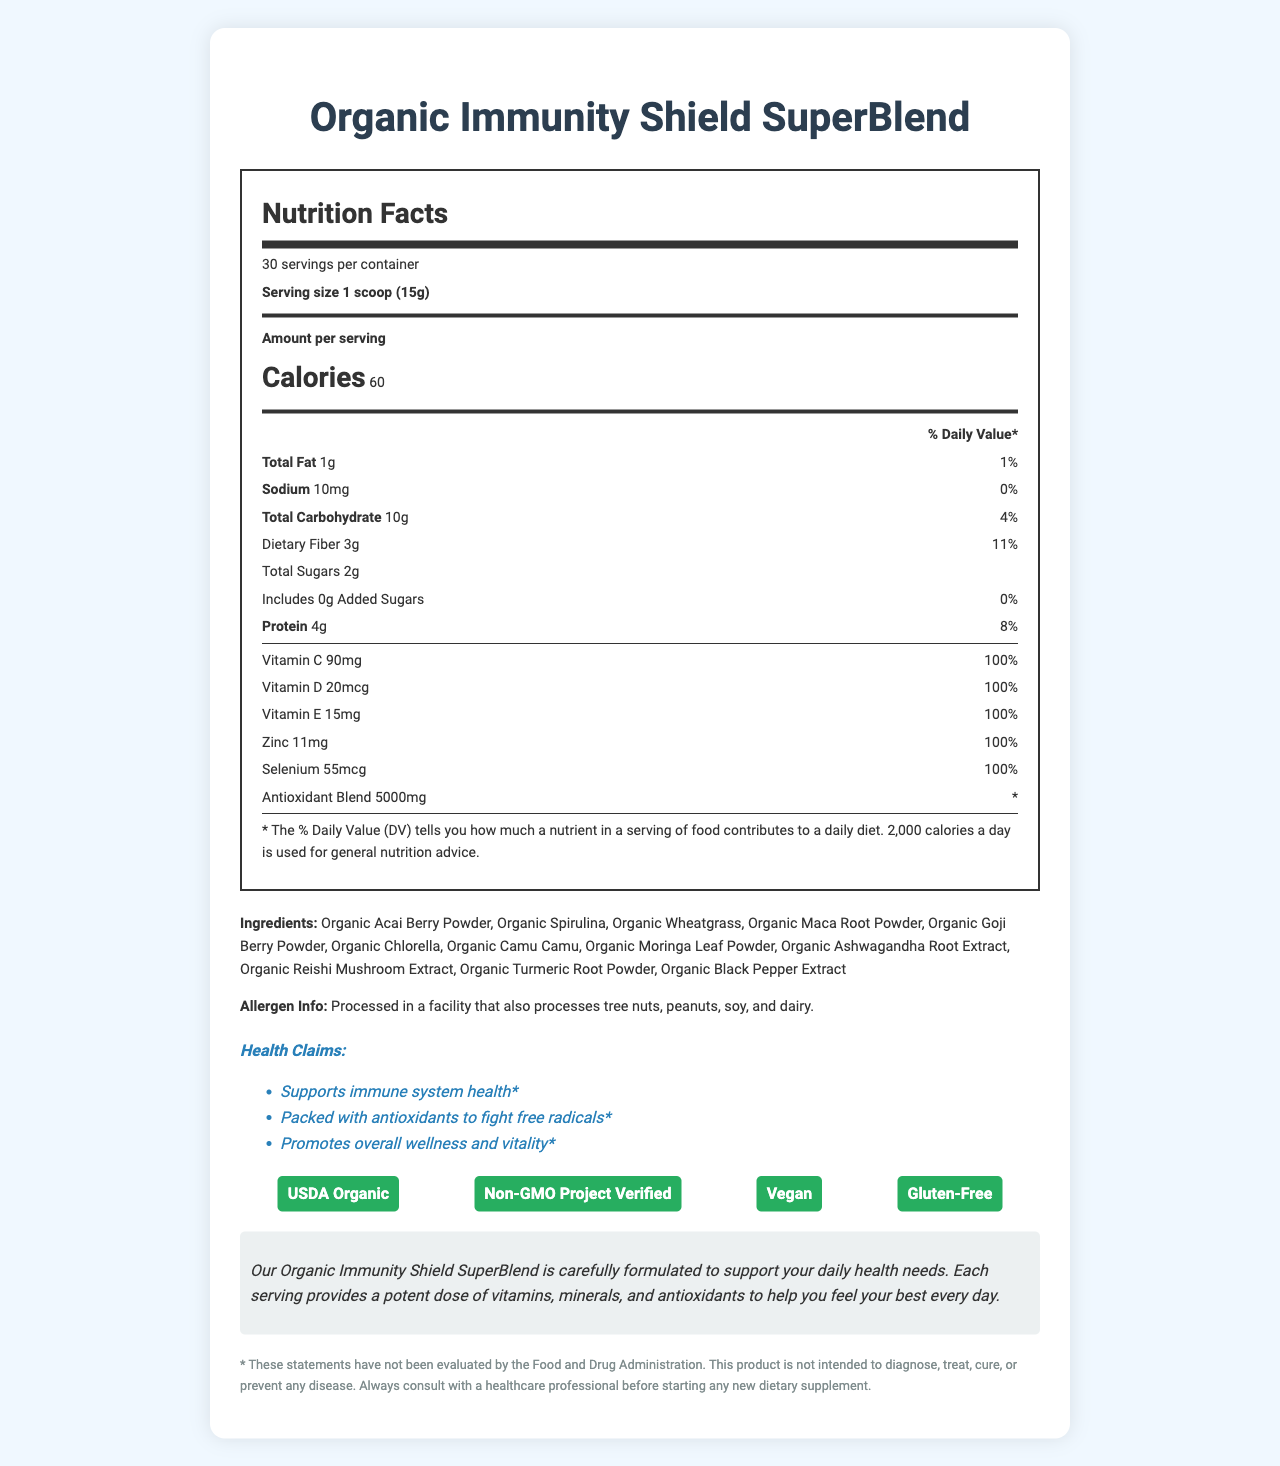what is the serving size? The document states that the serving size for the Organic Immunity Shield SuperBlend is 1 scoop equaling 15 grams.
Answer: 1 scoop (15g) how many servings are in one container? The document shows that there are 30 servings per container.
Answer: 30 servings how many calories are in one serving? According to the document, each serving of the Organic Immunity Shield SuperBlend contains 60 calories.
Answer: 60 calories how much dietary fiber is in one serving? The document indicates that there are 3 grams of dietary fiber in each serving.
Answer: 3g which vitamins provide 100% of the daily value per serving? The document lists Vitamin C, Vitamin D, Vitamin E, Zinc, and Selenium as providing 100% of the daily value per serving.
Answer: Vitamin C, Vitamin D, Vitamin E, Zinc, Selenium which claim is NOT mentioned as a health benefit of this product? A. Enhances sleep quality B. Supports immune system health C. Promotes overall wellness and vitality The document lists health claims including supporting immune system health and promoting overall wellness and vitality, but does not mention enhancing sleep quality.
Answer: A. Enhances sleep quality which of the following ingredients are NOT in the Organic Immunity Shield SuperBlend? A. Organic Matcha Powder B. Organic Goji Berry Powder C. Organic Spirulina The document lists Organic Goji Berry Powder and Organic Spirulina as ingredients but does not mention Organic Matcha Powder.
Answer: A. Organic Matcha Powder Is this product vegan? (Yes/No) The document includes a certification that states the product is "Vegan."
Answer: Yes summarize the main idea of this document. The document provides comprehensive information about the Organic Immunity Shield SuperBlend, including its nutritional content, health benefits, ingredients, usage instructions, and certifications.
Answer: The Organic Immunity Shield SuperBlend is a USDA Organic, Non-GMO, vegan, and gluten-free superfood powder that supports immune system health with a serving size of 1 scoop (15g). Each serving has 60 calories and provides 100% daily value of several vitamins and minerals, along with an antioxidant blend. The product is intended for daily use to promote overall wellness. are there any added sugars in the product? The document specifies that there are 0 grams of added sugars per serving.
Answer: No what percentage of daily value of protein does each serving contain? The document indicates that each serving provides 8% of the daily value for protein.
Answer: 8% how are consumers advised to consume this product? The document provides usage instructions advising consumers to mix 1 scoop with 8-10 oz of water, juice, or a favorite smoothie and consume it daily for optimal results.
Answer: Mix 1 scoop with 8-10 oz of water, juice, or your favorite smoothie. Consume daily for optimal results. Is this product processed in a facility that also processes peanuts? (Yes/No) The document mentions that the product is processed in a facility that also processes tree nuts, peanuts, soy, and dairy.
Answer: Yes how much of the antioxidant blend is in one serving? The document states that each serving contains 5000mg of the antioxidant blend.
Answer: 5000mg can the product diagnose, treat, cure, or prevent any disease? The document includes a disclaimer stating that the product is not intended to diagnose, treat, cure, or prevent any disease.
Answer: No 